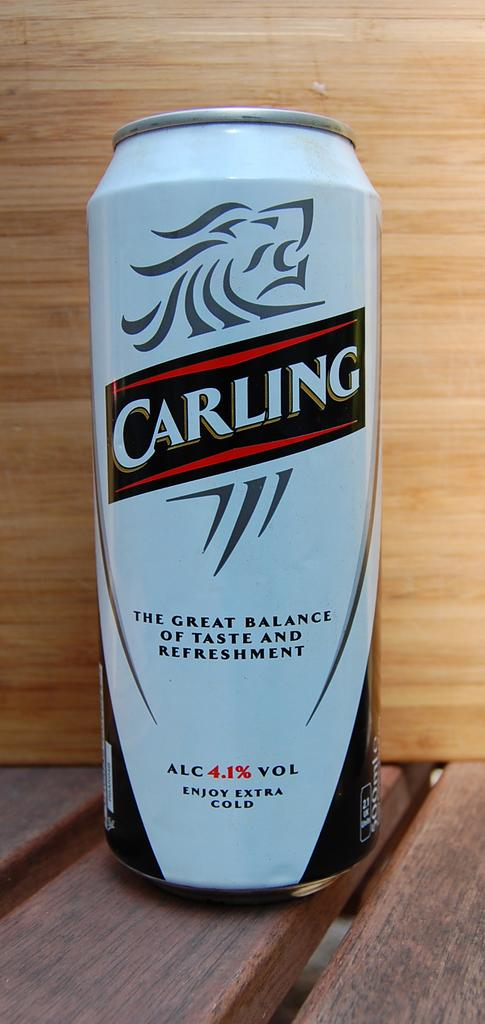<image>
Render a clear and concise summary of the photo. The Carling motto is, "The great balance of taste and refreshment." 